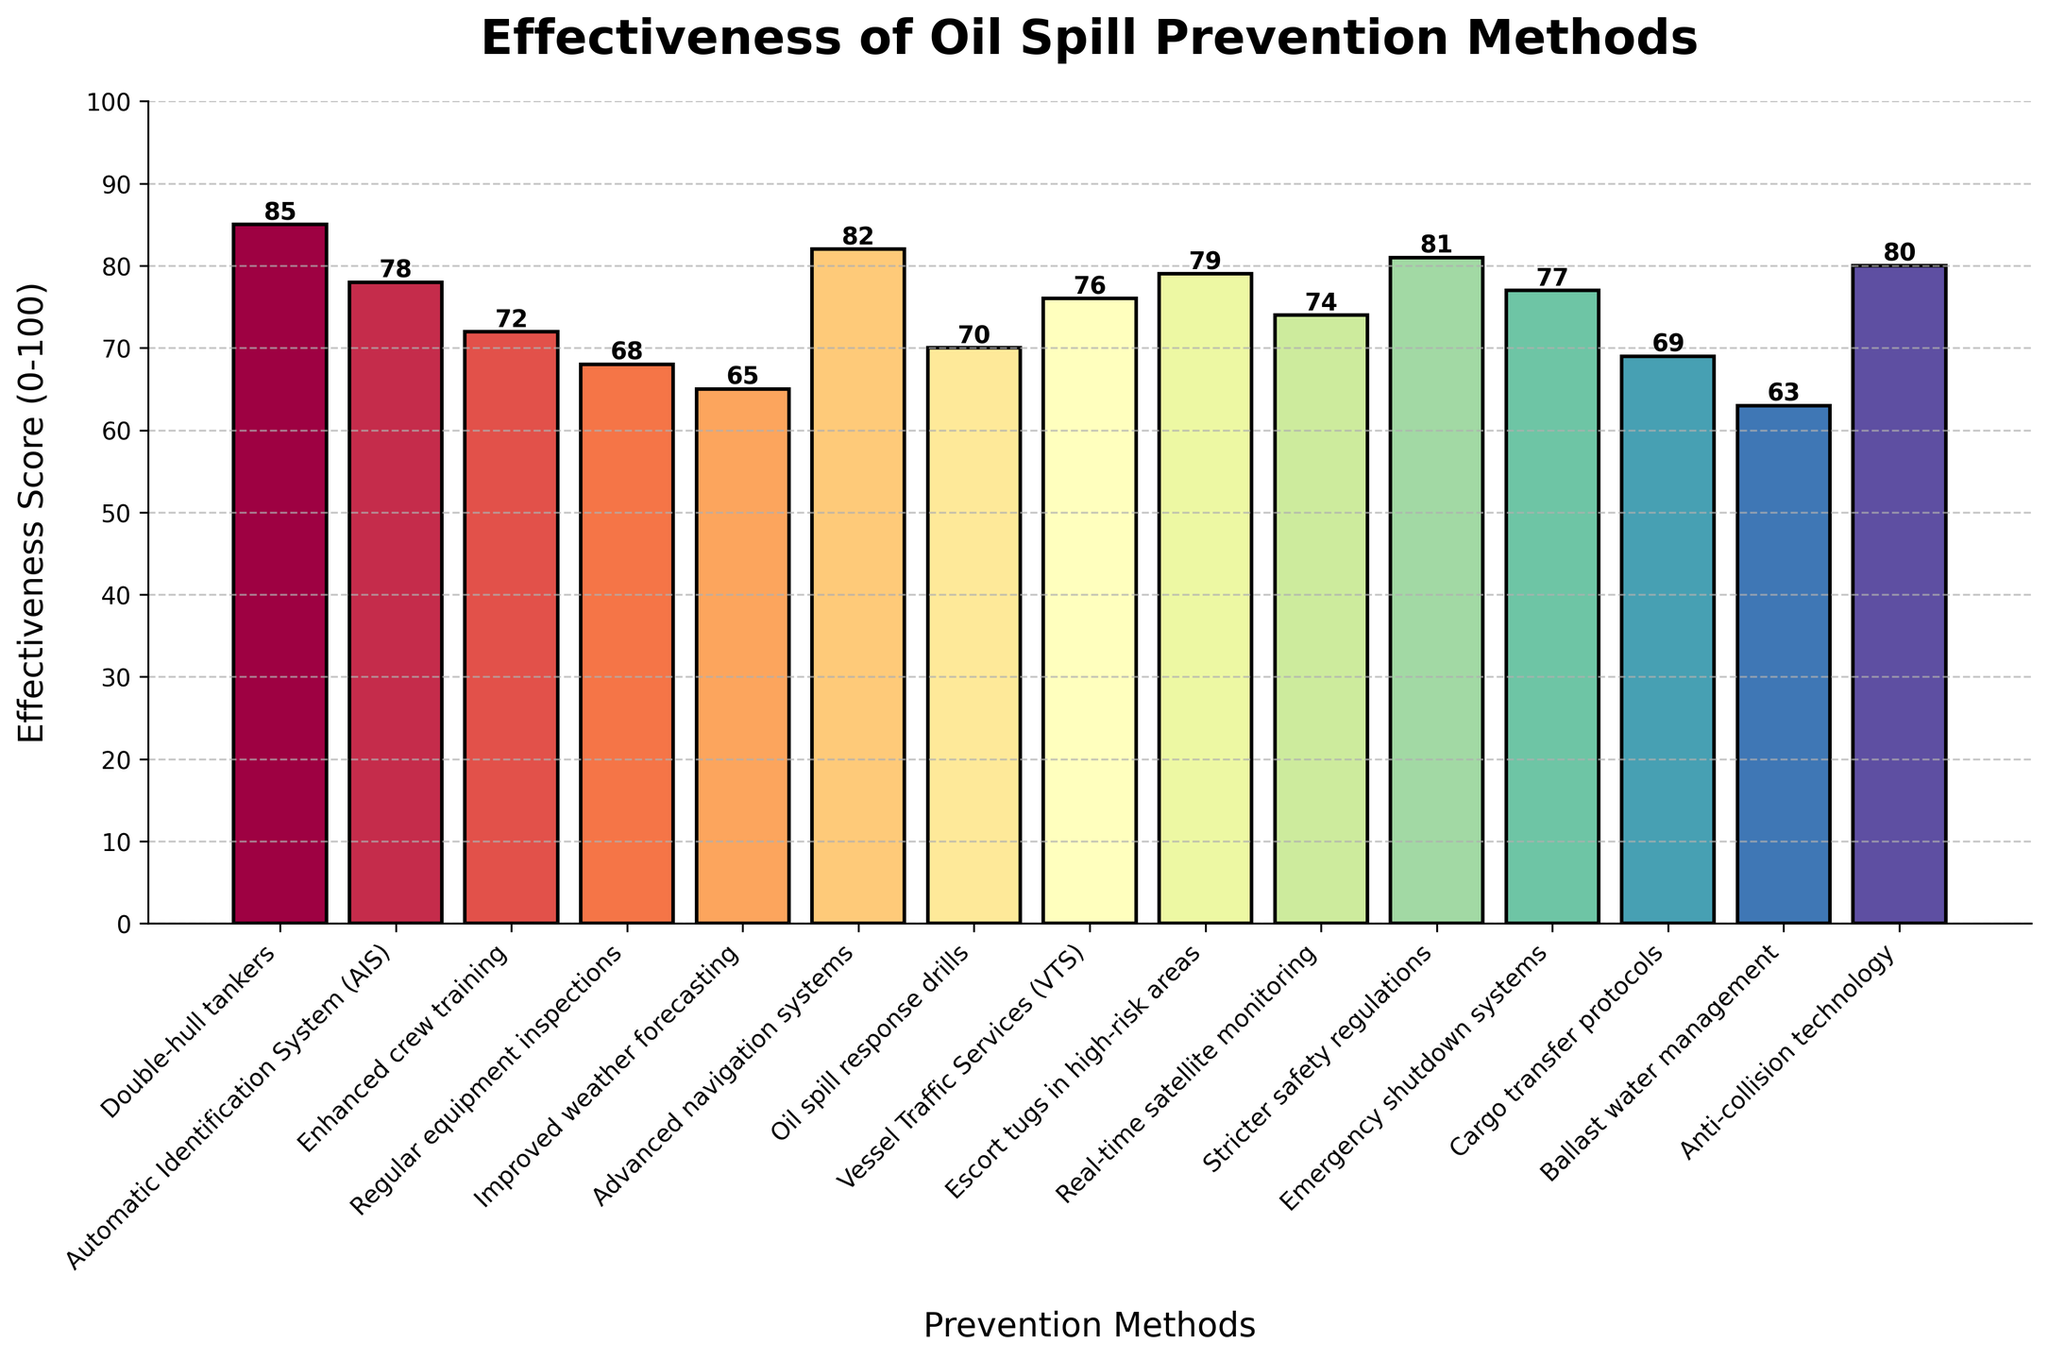Which oil spill prevention method has the highest effectiveness score? The highest bar in the chart represents the method with the highest effectiveness score. Here, the "Double-hull tankers" method has the highest score of 85.
Answer: Double-hull tankers How many methods have an effectiveness score of 75 or higher? To answer this, count the bars that reach a height of 75 or above. The methods are: "Double-hull tankers", "Advanced navigation systems", "Stricter safety regulations", "Anti-collision technology", "Escort tugs in high-risk areas", "Automatic Identification System (AIS)", and "Emergency shutdown systems". There are 7 methods in total.
Answer: 7 Which method has a lower effectiveness score: "AIS" or "VTS"? Compare the heights of the bars labeled "Automatic Identification System (AIS)" and "Vessel Traffic Services (VTS)". The effectiveness score for AIS is 78, while VTS is 76. Thus, VTS has a lower score.
Answer: Vessel Traffic Services (VTS) What is the combined effectiveness score of "Enhanced crew training" and "Regular equipment inspections"? Add the scores of these two methods: "Enhanced crew training" (72) and "Regular equipment inspections" (68). The sum is 72 + 68 = 140.
Answer: 140 What's the average effectiveness score of the methods shown? To find the average, sum all the effectiveness scores and divide by the number of methods. Sum: 85 + 78 + 72 + 68 + 65 + 82 + 70 + 76 + 79 + 74 + 81 + 77 + 69 + 63 + 80 = 1119. Number of methods: 15. Average = 1119 / 15 = 74.6.
Answer: 74.6 Is "Ballast water management" more effective than "Improved weather forecasting"? Compare the heights of their respective bars. "Ballast water management" has a score of 63, while "Improved weather forecasting" has a score of 65. Therefore, "Ballast water management" is less effective.
Answer: No Which method has the lowest effectiveness score? Observe the shortest bar in the chart. "Ballast water management" is the shortest, indicating it has the lowest score of 63.
Answer: Ballast water management What is the score difference between the highest and lowest effectiveness methods? Subtract the lowest score from the highest score. Highest: Double-hull tankers (85), Lowest: Ballast water management (63). Difference: 85 - 63 = 22.
Answer: 22 Which methods have a score between 70 and 80? Identify the bars that fall within the 70-80 range. The methods are: "Enhanced crew training" (72), "Oil spill response drills" (70), "Vessel Traffic Services (VTS)" (76), "Real-time satellite monitoring" (74), "Emergency shutdown systems" (77), and "Cargo transfer protocols" (69 falls just short but isn't included). So, there are six methods in this range.
Answer: 6 What is the median effectiveness score of the methods? To find the median, list all scores in ascending order and find the middle value. Sorted: 63, 65, 68, 69, 70, 72, 74, 76, 77, 78, 79, 80, 81, 82, 85. The median is the 8th value (middle value in an odd-numbered list), which is 76.
Answer: 76 